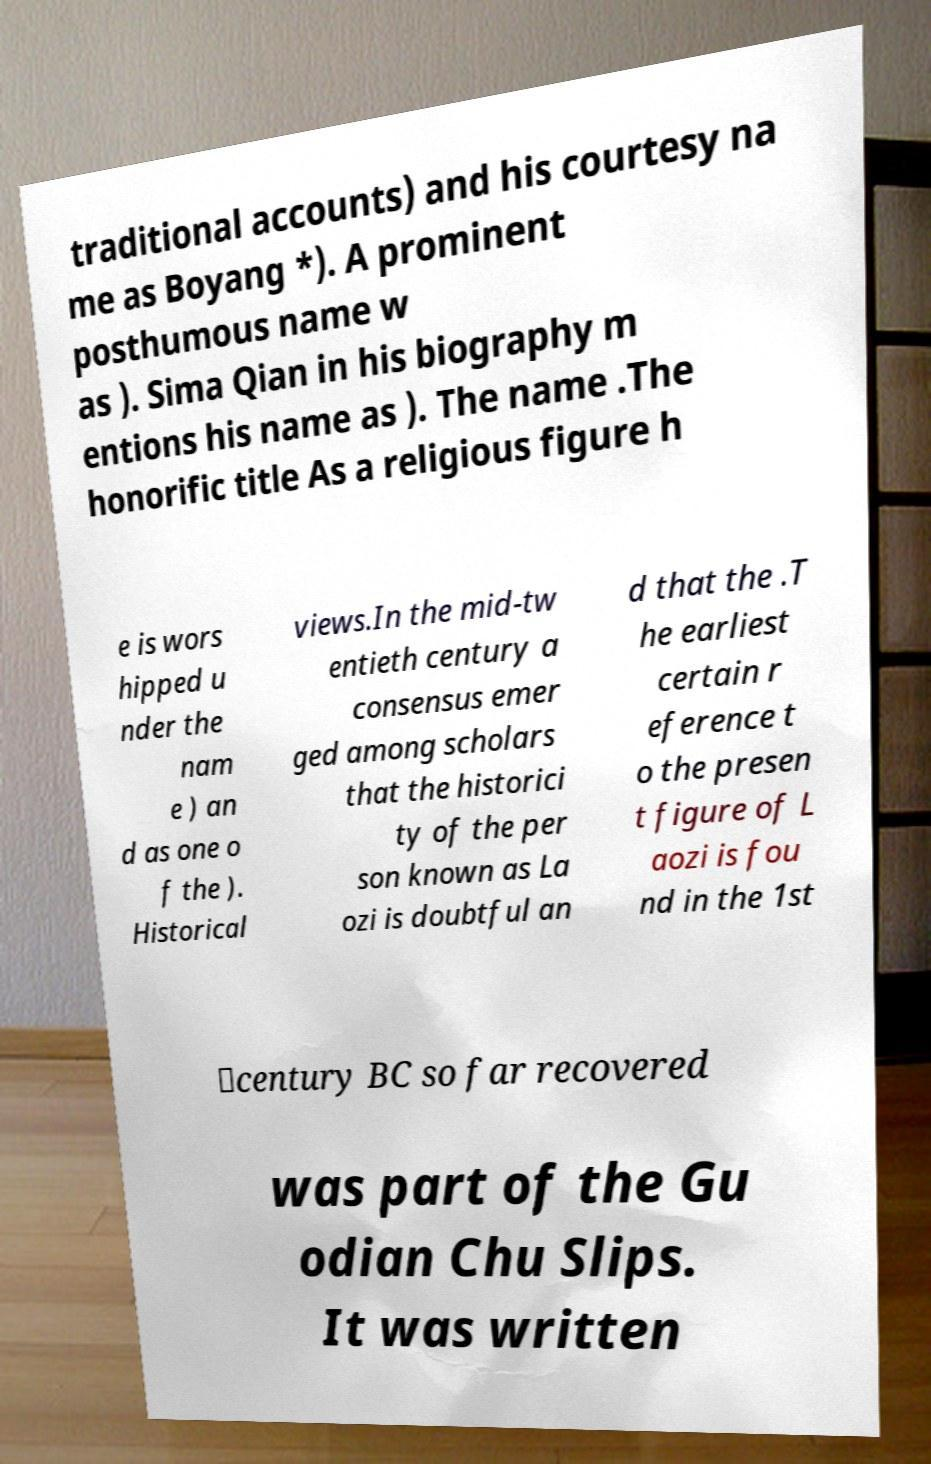Can you read and provide the text displayed in the image?This photo seems to have some interesting text. Can you extract and type it out for me? traditional accounts) and his courtesy na me as Boyang *). A prominent posthumous name w as ). Sima Qian in his biography m entions his name as ). The name .The honorific title As a religious figure h e is wors hipped u nder the nam e ) an d as one o f the ). Historical views.In the mid-tw entieth century a consensus emer ged among scholars that the historici ty of the per son known as La ozi is doubtful an d that the .T he earliest certain r eference t o the presen t figure of L aozi is fou nd in the 1st ‑century BC so far recovered was part of the Gu odian Chu Slips. It was written 